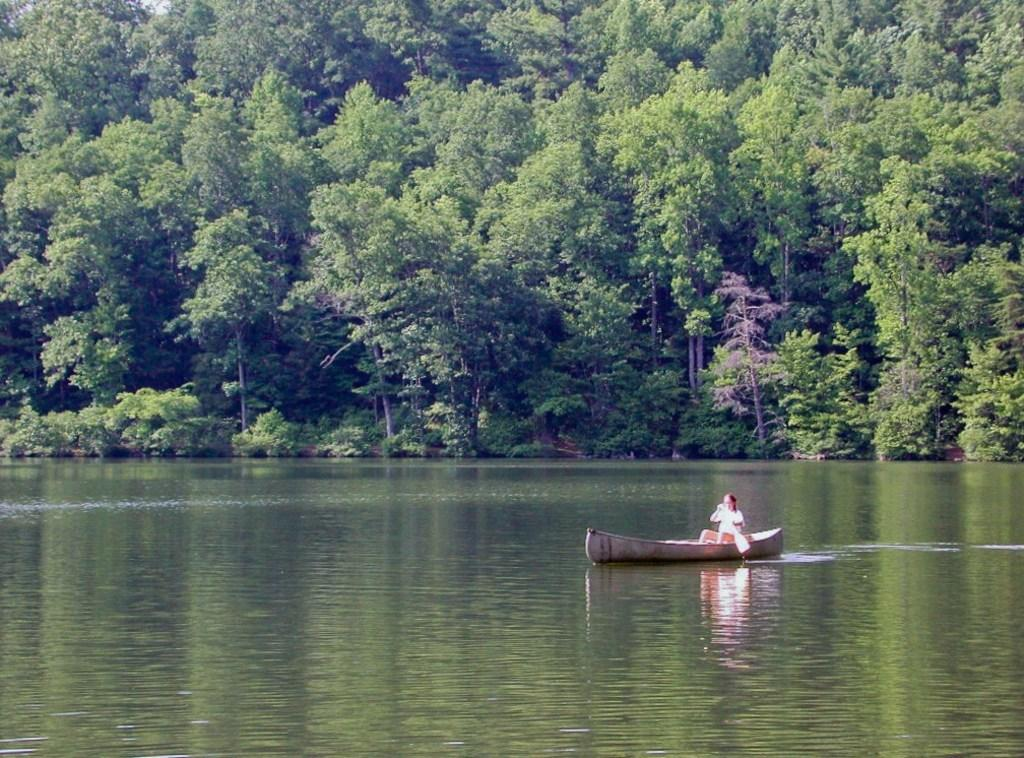What is the person in the image doing? The person is sitting on a boat and holding a paddle. What is the person using to move the boat? The person is using the paddle to move the boat. What can be seen in the background of the image? There are trees in the background of the image. What is the primary element surrounding the boat? There is water visible in the image. What type of death is depicted in the image? There is no depiction of death in the image; it features a person sitting on a boat and holding a paddle. What type of canvas is used to create the image? The question assumes the image is a painting or drawing, which is not mentioned in the provided facts. The medium of the image is not specified. 